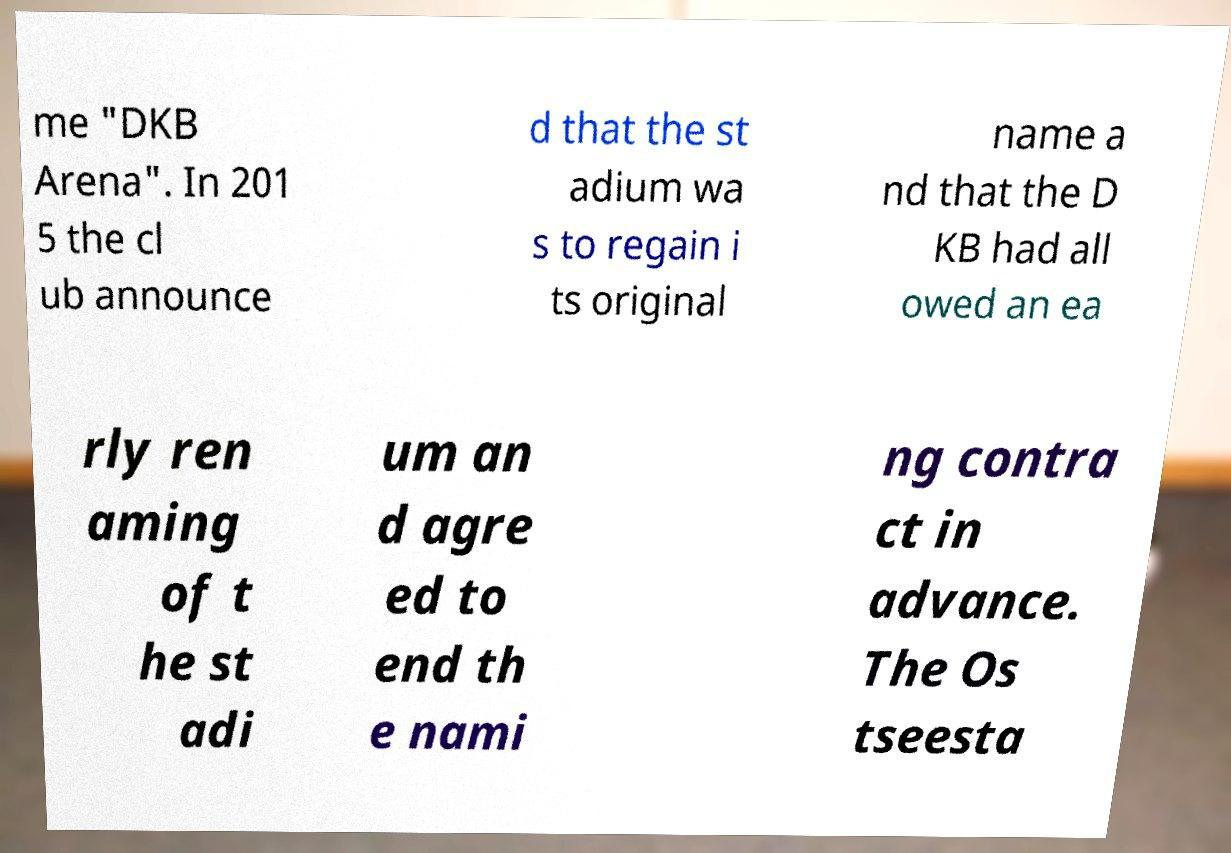Could you extract and type out the text from this image? me "DKB Arena". In 201 5 the cl ub announce d that the st adium wa s to regain i ts original name a nd that the D KB had all owed an ea rly ren aming of t he st adi um an d agre ed to end th e nami ng contra ct in advance. The Os tseesta 